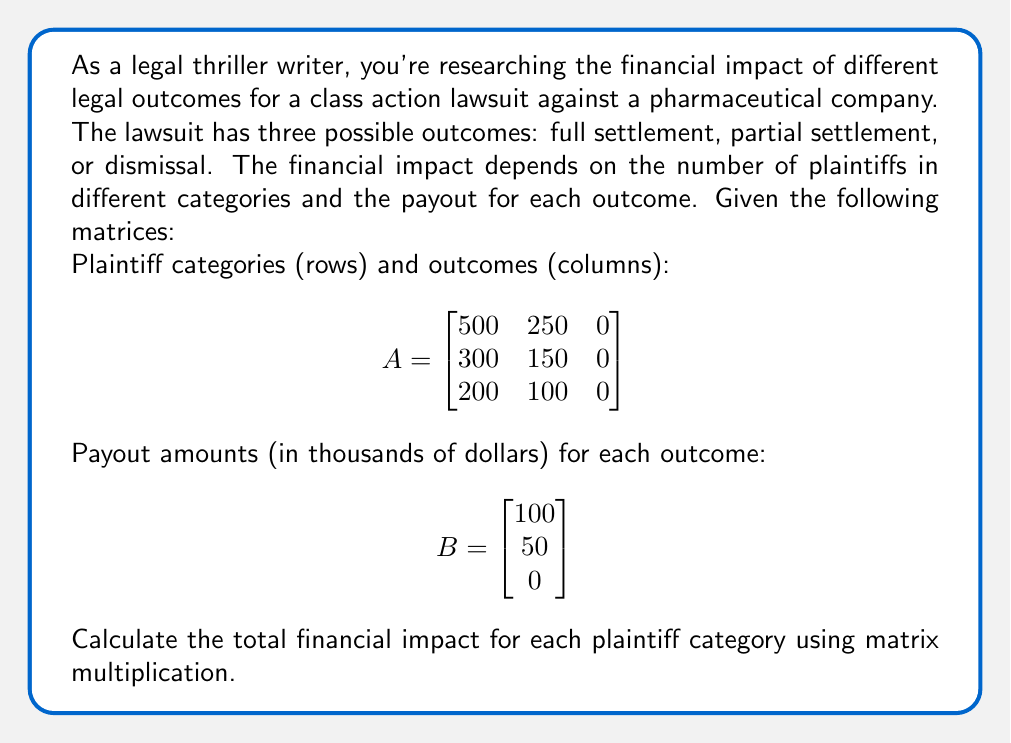Show me your answer to this math problem. To solve this problem, we need to multiply matrix A by matrix B. This multiplication will give us the total financial impact for each plaintiff category across all possible outcomes.

Step 1: Set up the matrix multiplication
$$C = A \times B$$

Step 2: Perform the matrix multiplication
$$C = \begin{bmatrix}
500 & 250 & 0 \\
300 & 150 & 0 \\
200 & 100 & 0
\end{bmatrix} \times \begin{bmatrix}
100 \\
50 \\
0
\end{bmatrix}$$

Step 3: Calculate each element of the resulting matrix
For the first row:
$c_{11} = (500 \times 100) + (250 \times 50) + (0 \times 0) = 50,000 + 12,500 + 0 = 62,500$

For the second row:
$c_{21} = (300 \times 100) + (150 \times 50) + (0 \times 0) = 30,000 + 7,500 + 0 = 37,500$

For the third row:
$c_{31} = (200 \times 100) + (100 \times 50) + (0 \times 0) = 20,000 + 5,000 + 0 = 25,000$

Step 4: Write the final result matrix
$$C = \begin{bmatrix}
62,500 \\
37,500 \\
25,000
\end{bmatrix}$$

This result shows the total financial impact (in thousands of dollars) for each plaintiff category.
Answer: $$\begin{bmatrix}
62,500 \\
37,500 \\
25,000
\end{bmatrix}$$ (in thousands of dollars) 